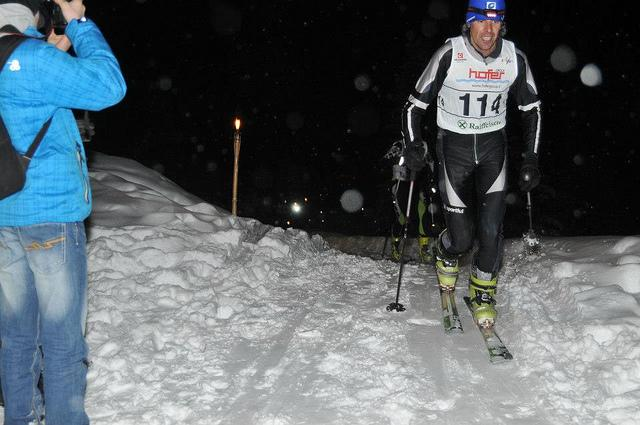What is that light in the distance called? Please explain your reasoning. torch. The street lamps are on in public places. 